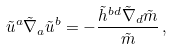Convert formula to latex. <formula><loc_0><loc_0><loc_500><loc_500>\tilde { u } ^ { a } \tilde { \nabla } _ { a } \tilde { u } ^ { b } = - \frac { \tilde { h } ^ { b d } \tilde { \nabla } _ { d } \tilde { m } } { \tilde { m } } \, ,</formula> 